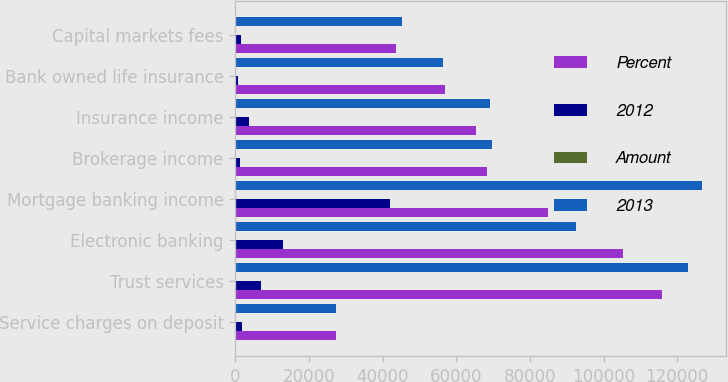Convert chart. <chart><loc_0><loc_0><loc_500><loc_500><stacked_bar_chart><ecel><fcel>Service charges on deposit<fcel>Trust services<fcel>Electronic banking<fcel>Mortgage banking income<fcel>Brokerage income<fcel>Insurance income<fcel>Bank owned life insurance<fcel>Capital markets fees<nl><fcel>Percent<fcel>27389<fcel>115972<fcel>105401<fcel>84887<fcel>68277<fcel>65473<fcel>57048<fcel>43731<nl><fcel>2012<fcel>1939<fcel>7035<fcel>12810<fcel>41968<fcel>1347<fcel>3791<fcel>629<fcel>1489<nl><fcel>Amount<fcel>1<fcel>6<fcel>14<fcel>33<fcel>2<fcel>5<fcel>1<fcel>3<nl><fcel>2013<fcel>27389<fcel>123007<fcel>92591<fcel>126855<fcel>69624<fcel>69264<fcel>56419<fcel>45220<nl></chart> 